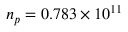<formula> <loc_0><loc_0><loc_500><loc_500>n _ { p } = 0 . 7 8 3 \times 1 0 ^ { 1 1 }</formula> 